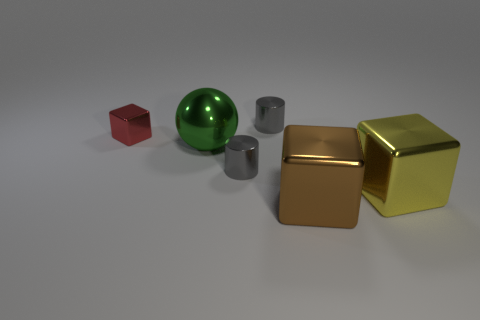Subtract all gray cylinders. How many were subtracted if there are1gray cylinders left? 1 Add 2 large blocks. How many objects exist? 8 Subtract all spheres. How many objects are left? 5 Add 2 large metal blocks. How many large metal blocks exist? 4 Subtract 0 red balls. How many objects are left? 6 Subtract all tiny gray metallic objects. Subtract all metallic cubes. How many objects are left? 1 Add 5 small blocks. How many small blocks are left? 6 